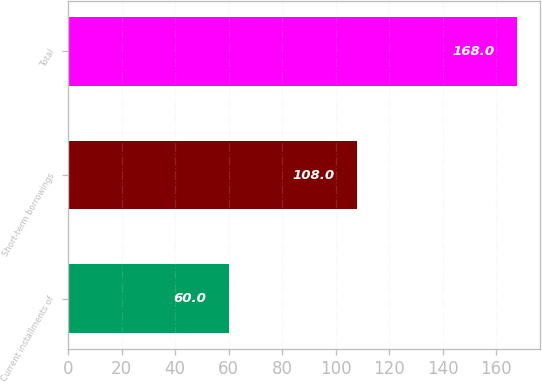Convert chart. <chart><loc_0><loc_0><loc_500><loc_500><bar_chart><fcel>Current installments of<fcel>Short-term borrowings<fcel>Total<nl><fcel>60<fcel>108<fcel>168<nl></chart> 